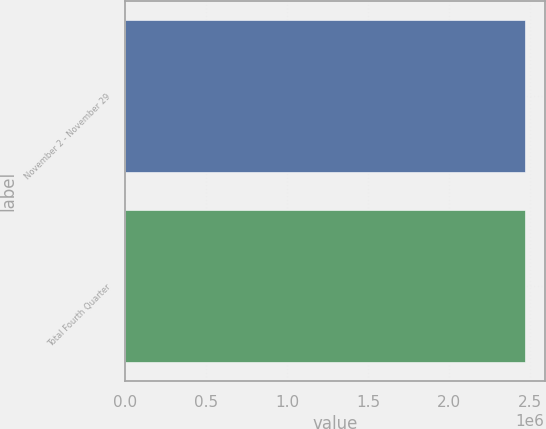<chart> <loc_0><loc_0><loc_500><loc_500><bar_chart><fcel>November 2 - November 29<fcel>Total Fourth Quarter<nl><fcel>2.4673e+06<fcel>2.4673e+06<nl></chart> 